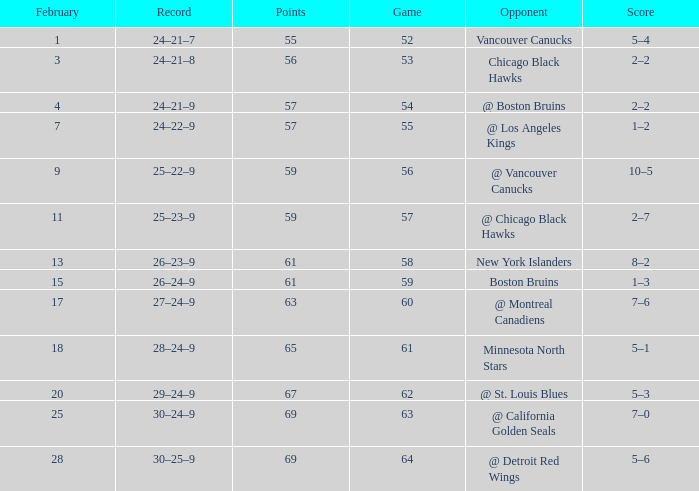How many february games had a record of 29–24–9? 20.0. 